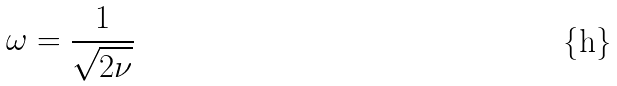Convert formula to latex. <formula><loc_0><loc_0><loc_500><loc_500>\omega = \frac { 1 } { \sqrt { 2 \nu } }</formula> 